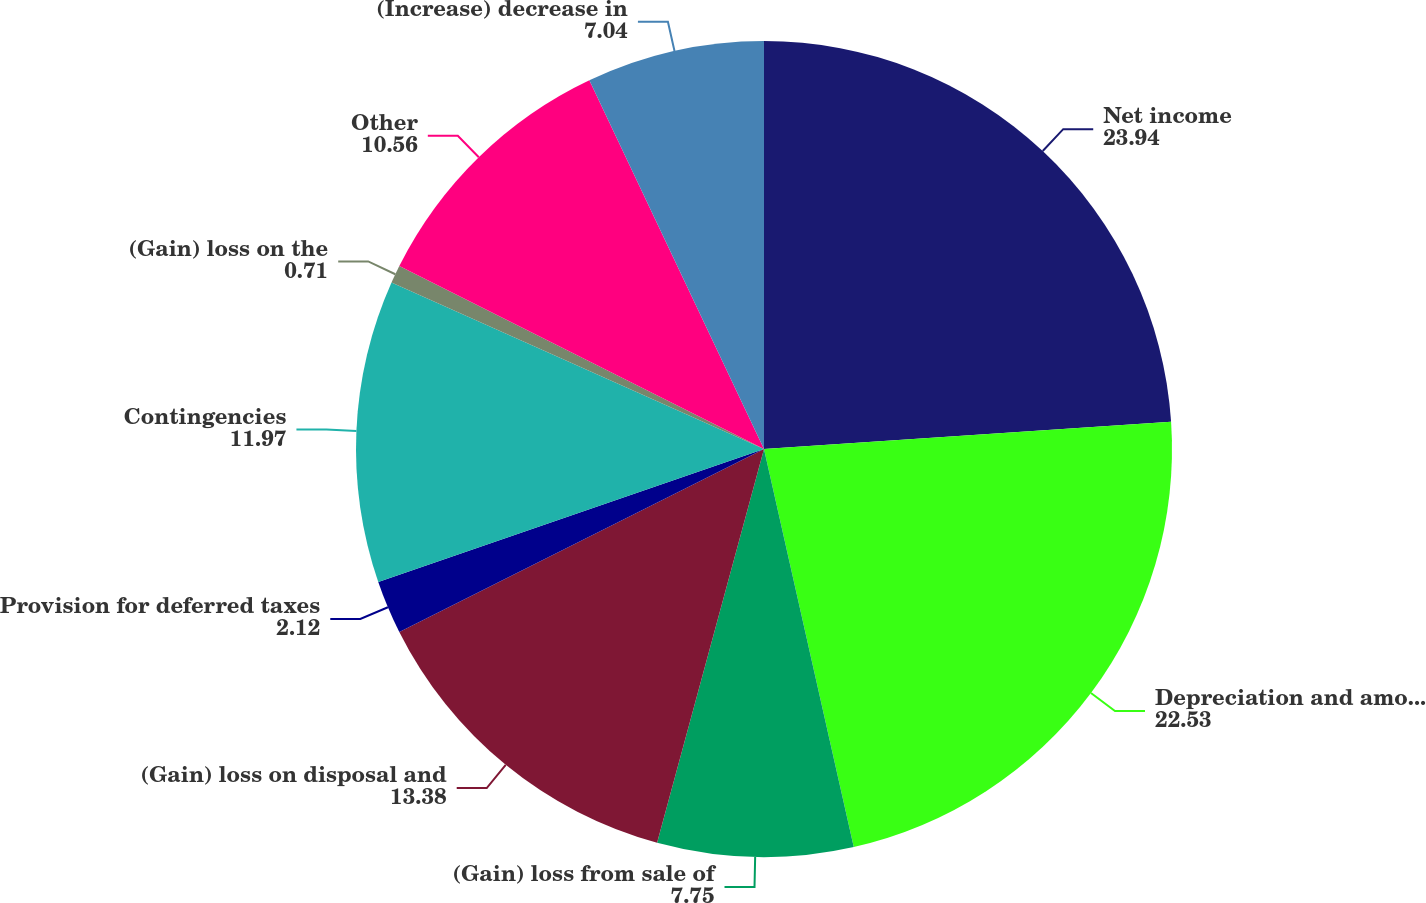Convert chart. <chart><loc_0><loc_0><loc_500><loc_500><pie_chart><fcel>Net income<fcel>Depreciation and amortization<fcel>(Gain) loss from sale of<fcel>(Gain) loss on disposal and<fcel>Provision for deferred taxes<fcel>Contingencies<fcel>(Gain) loss on the<fcel>Other<fcel>(Increase) decrease in<nl><fcel>23.94%<fcel>22.53%<fcel>7.75%<fcel>13.38%<fcel>2.12%<fcel>11.97%<fcel>0.71%<fcel>10.56%<fcel>7.04%<nl></chart> 